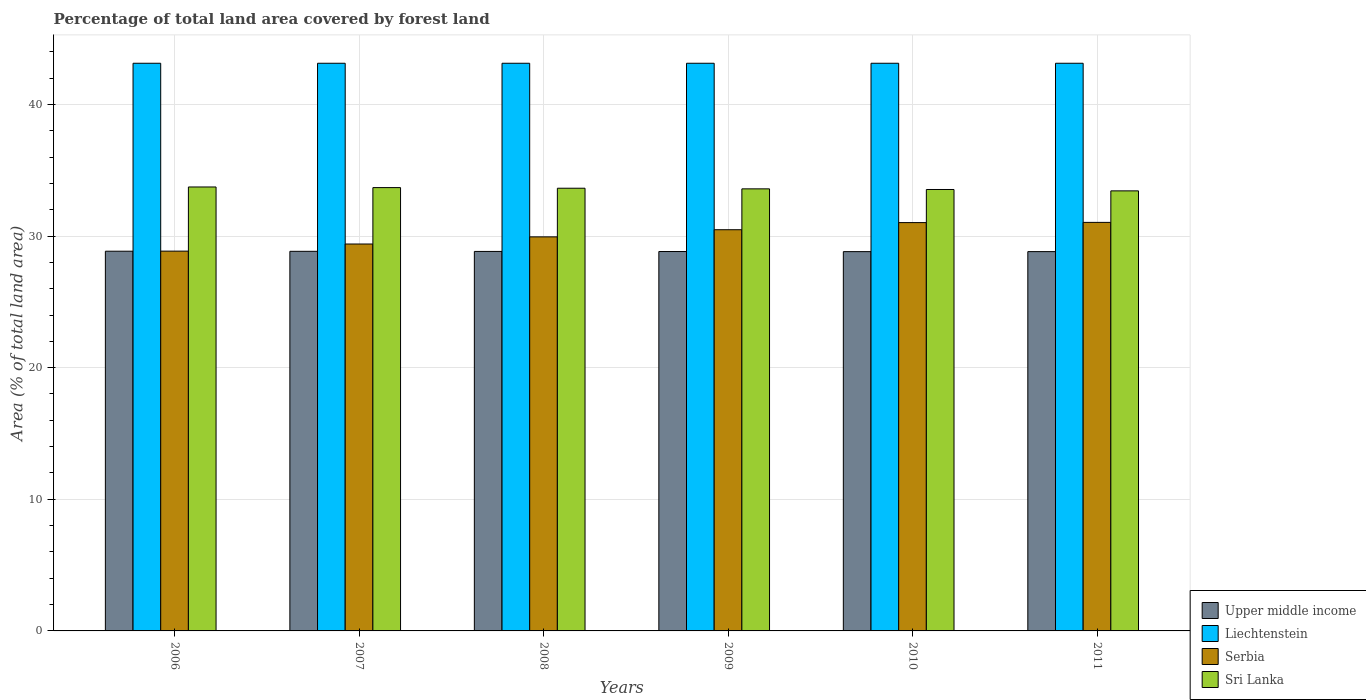How many different coloured bars are there?
Offer a very short reply. 4. Are the number of bars per tick equal to the number of legend labels?
Your answer should be compact. Yes. How many bars are there on the 5th tick from the left?
Provide a short and direct response. 4. What is the label of the 5th group of bars from the left?
Your response must be concise. 2010. What is the percentage of forest land in Sri Lanka in 2008?
Offer a terse response. 33.63. Across all years, what is the maximum percentage of forest land in Upper middle income?
Provide a short and direct response. 28.85. Across all years, what is the minimum percentage of forest land in Upper middle income?
Your answer should be very brief. 28.81. In which year was the percentage of forest land in Liechtenstein maximum?
Offer a very short reply. 2006. In which year was the percentage of forest land in Serbia minimum?
Provide a short and direct response. 2006. What is the total percentage of forest land in Sri Lanka in the graph?
Offer a terse response. 201.59. What is the difference between the percentage of forest land in Sri Lanka in 2006 and that in 2008?
Give a very brief answer. 0.1. What is the difference between the percentage of forest land in Liechtenstein in 2008 and the percentage of forest land in Sri Lanka in 2011?
Ensure brevity in your answer.  9.69. What is the average percentage of forest land in Sri Lanka per year?
Offer a terse response. 33.6. In the year 2011, what is the difference between the percentage of forest land in Liechtenstein and percentage of forest land in Serbia?
Offer a very short reply. 12.09. What is the ratio of the percentage of forest land in Sri Lanka in 2010 to that in 2011?
Keep it short and to the point. 1. Is the difference between the percentage of forest land in Liechtenstein in 2007 and 2010 greater than the difference between the percentage of forest land in Serbia in 2007 and 2010?
Keep it short and to the point. Yes. What is the difference between the highest and the second highest percentage of forest land in Serbia?
Offer a terse response. 0.02. What is the difference between the highest and the lowest percentage of forest land in Serbia?
Offer a very short reply. 2.18. In how many years, is the percentage of forest land in Upper middle income greater than the average percentage of forest land in Upper middle income taken over all years?
Your response must be concise. 3. What does the 2nd bar from the left in 2008 represents?
Offer a terse response. Liechtenstein. What does the 3rd bar from the right in 2011 represents?
Your answer should be compact. Liechtenstein. How many years are there in the graph?
Your answer should be very brief. 6. Are the values on the major ticks of Y-axis written in scientific E-notation?
Your response must be concise. No. How are the legend labels stacked?
Provide a succinct answer. Vertical. What is the title of the graph?
Keep it short and to the point. Percentage of total land area covered by forest land. Does "Somalia" appear as one of the legend labels in the graph?
Give a very brief answer. No. What is the label or title of the X-axis?
Provide a succinct answer. Years. What is the label or title of the Y-axis?
Give a very brief answer. Area (% of total land area). What is the Area (% of total land area) of Upper middle income in 2006?
Your answer should be very brief. 28.85. What is the Area (% of total land area) in Liechtenstein in 2006?
Your answer should be very brief. 43.12. What is the Area (% of total land area) in Serbia in 2006?
Provide a short and direct response. 28.85. What is the Area (% of total land area) of Sri Lanka in 2006?
Ensure brevity in your answer.  33.73. What is the Area (% of total land area) of Upper middle income in 2007?
Keep it short and to the point. 28.84. What is the Area (% of total land area) of Liechtenstein in 2007?
Offer a very short reply. 43.12. What is the Area (% of total land area) in Serbia in 2007?
Ensure brevity in your answer.  29.39. What is the Area (% of total land area) in Sri Lanka in 2007?
Give a very brief answer. 33.68. What is the Area (% of total land area) in Upper middle income in 2008?
Offer a very short reply. 28.83. What is the Area (% of total land area) of Liechtenstein in 2008?
Offer a very short reply. 43.12. What is the Area (% of total land area) of Serbia in 2008?
Keep it short and to the point. 29.94. What is the Area (% of total land area) of Sri Lanka in 2008?
Provide a succinct answer. 33.63. What is the Area (% of total land area) in Upper middle income in 2009?
Your response must be concise. 28.82. What is the Area (% of total land area) in Liechtenstein in 2009?
Your response must be concise. 43.12. What is the Area (% of total land area) of Serbia in 2009?
Provide a succinct answer. 30.48. What is the Area (% of total land area) of Sri Lanka in 2009?
Ensure brevity in your answer.  33.58. What is the Area (% of total land area) of Upper middle income in 2010?
Make the answer very short. 28.81. What is the Area (% of total land area) in Liechtenstein in 2010?
Keep it short and to the point. 43.12. What is the Area (% of total land area) in Serbia in 2010?
Offer a terse response. 31.02. What is the Area (% of total land area) of Sri Lanka in 2010?
Give a very brief answer. 33.54. What is the Area (% of total land area) of Upper middle income in 2011?
Offer a very short reply. 28.82. What is the Area (% of total land area) of Liechtenstein in 2011?
Offer a very short reply. 43.12. What is the Area (% of total land area) of Serbia in 2011?
Offer a very short reply. 31.04. What is the Area (% of total land area) in Sri Lanka in 2011?
Give a very brief answer. 33.43. Across all years, what is the maximum Area (% of total land area) of Upper middle income?
Keep it short and to the point. 28.85. Across all years, what is the maximum Area (% of total land area) in Liechtenstein?
Provide a succinct answer. 43.12. Across all years, what is the maximum Area (% of total land area) in Serbia?
Keep it short and to the point. 31.04. Across all years, what is the maximum Area (% of total land area) of Sri Lanka?
Provide a short and direct response. 33.73. Across all years, what is the minimum Area (% of total land area) in Upper middle income?
Your response must be concise. 28.81. Across all years, what is the minimum Area (% of total land area) of Liechtenstein?
Your answer should be very brief. 43.12. Across all years, what is the minimum Area (% of total land area) in Serbia?
Provide a succinct answer. 28.85. Across all years, what is the minimum Area (% of total land area) of Sri Lanka?
Keep it short and to the point. 33.43. What is the total Area (% of total land area) of Upper middle income in the graph?
Offer a very short reply. 172.97. What is the total Area (% of total land area) in Liechtenstein in the graph?
Provide a succinct answer. 258.75. What is the total Area (% of total land area) of Serbia in the graph?
Give a very brief answer. 180.72. What is the total Area (% of total land area) of Sri Lanka in the graph?
Your response must be concise. 201.59. What is the difference between the Area (% of total land area) in Upper middle income in 2006 and that in 2007?
Keep it short and to the point. 0.01. What is the difference between the Area (% of total land area) of Serbia in 2006 and that in 2007?
Your answer should be very brief. -0.54. What is the difference between the Area (% of total land area) in Sri Lanka in 2006 and that in 2007?
Your answer should be very brief. 0.05. What is the difference between the Area (% of total land area) of Upper middle income in 2006 and that in 2008?
Provide a short and direct response. 0.02. What is the difference between the Area (% of total land area) in Serbia in 2006 and that in 2008?
Your answer should be very brief. -1.08. What is the difference between the Area (% of total land area) of Sri Lanka in 2006 and that in 2008?
Keep it short and to the point. 0.1. What is the difference between the Area (% of total land area) in Upper middle income in 2006 and that in 2009?
Ensure brevity in your answer.  0.02. What is the difference between the Area (% of total land area) in Serbia in 2006 and that in 2009?
Ensure brevity in your answer.  -1.63. What is the difference between the Area (% of total land area) in Sri Lanka in 2006 and that in 2009?
Your answer should be very brief. 0.14. What is the difference between the Area (% of total land area) of Upper middle income in 2006 and that in 2010?
Ensure brevity in your answer.  0.03. What is the difference between the Area (% of total land area) in Serbia in 2006 and that in 2010?
Provide a short and direct response. -2.17. What is the difference between the Area (% of total land area) of Sri Lanka in 2006 and that in 2010?
Make the answer very short. 0.19. What is the difference between the Area (% of total land area) of Upper middle income in 2006 and that in 2011?
Offer a terse response. 0.03. What is the difference between the Area (% of total land area) of Liechtenstein in 2006 and that in 2011?
Your response must be concise. 0. What is the difference between the Area (% of total land area) in Serbia in 2006 and that in 2011?
Keep it short and to the point. -2.18. What is the difference between the Area (% of total land area) in Sri Lanka in 2006 and that in 2011?
Provide a short and direct response. 0.3. What is the difference between the Area (% of total land area) of Upper middle income in 2007 and that in 2008?
Offer a very short reply. 0.01. What is the difference between the Area (% of total land area) in Serbia in 2007 and that in 2008?
Your answer should be compact. -0.54. What is the difference between the Area (% of total land area) in Sri Lanka in 2007 and that in 2008?
Provide a succinct answer. 0.05. What is the difference between the Area (% of total land area) of Upper middle income in 2007 and that in 2009?
Ensure brevity in your answer.  0.02. What is the difference between the Area (% of total land area) in Serbia in 2007 and that in 2009?
Make the answer very short. -1.08. What is the difference between the Area (% of total land area) in Sri Lanka in 2007 and that in 2009?
Provide a short and direct response. 0.1. What is the difference between the Area (% of total land area) of Upper middle income in 2007 and that in 2010?
Your response must be concise. 0.02. What is the difference between the Area (% of total land area) of Serbia in 2007 and that in 2010?
Offer a very short reply. -1.63. What is the difference between the Area (% of total land area) of Sri Lanka in 2007 and that in 2010?
Your response must be concise. 0.14. What is the difference between the Area (% of total land area) of Upper middle income in 2007 and that in 2011?
Keep it short and to the point. 0.02. What is the difference between the Area (% of total land area) of Serbia in 2007 and that in 2011?
Your response must be concise. -1.64. What is the difference between the Area (% of total land area) of Sri Lanka in 2007 and that in 2011?
Offer a very short reply. 0.25. What is the difference between the Area (% of total land area) in Upper middle income in 2008 and that in 2009?
Offer a very short reply. 0.01. What is the difference between the Area (% of total land area) in Serbia in 2008 and that in 2009?
Your answer should be very brief. -0.54. What is the difference between the Area (% of total land area) in Sri Lanka in 2008 and that in 2009?
Provide a short and direct response. 0.05. What is the difference between the Area (% of total land area) in Upper middle income in 2008 and that in 2010?
Make the answer very short. 0.02. What is the difference between the Area (% of total land area) of Serbia in 2008 and that in 2010?
Keep it short and to the point. -1.08. What is the difference between the Area (% of total land area) of Sri Lanka in 2008 and that in 2010?
Your answer should be very brief. 0.1. What is the difference between the Area (% of total land area) in Upper middle income in 2008 and that in 2011?
Provide a succinct answer. 0.01. What is the difference between the Area (% of total land area) of Serbia in 2008 and that in 2011?
Keep it short and to the point. -1.1. What is the difference between the Area (% of total land area) of Sri Lanka in 2008 and that in 2011?
Offer a terse response. 0.2. What is the difference between the Area (% of total land area) of Upper middle income in 2009 and that in 2010?
Provide a short and direct response. 0.01. What is the difference between the Area (% of total land area) of Serbia in 2009 and that in 2010?
Provide a succinct answer. -0.54. What is the difference between the Area (% of total land area) of Sri Lanka in 2009 and that in 2010?
Offer a very short reply. 0.05. What is the difference between the Area (% of total land area) of Upper middle income in 2009 and that in 2011?
Offer a very short reply. 0.01. What is the difference between the Area (% of total land area) of Serbia in 2009 and that in 2011?
Make the answer very short. -0.56. What is the difference between the Area (% of total land area) in Sri Lanka in 2009 and that in 2011?
Make the answer very short. 0.15. What is the difference between the Area (% of total land area) of Upper middle income in 2010 and that in 2011?
Your answer should be compact. -0. What is the difference between the Area (% of total land area) in Liechtenstein in 2010 and that in 2011?
Offer a terse response. 0. What is the difference between the Area (% of total land area) in Serbia in 2010 and that in 2011?
Your answer should be very brief. -0.02. What is the difference between the Area (% of total land area) of Sri Lanka in 2010 and that in 2011?
Your response must be concise. 0.11. What is the difference between the Area (% of total land area) of Upper middle income in 2006 and the Area (% of total land area) of Liechtenstein in 2007?
Give a very brief answer. -14.28. What is the difference between the Area (% of total land area) in Upper middle income in 2006 and the Area (% of total land area) in Serbia in 2007?
Give a very brief answer. -0.55. What is the difference between the Area (% of total land area) of Upper middle income in 2006 and the Area (% of total land area) of Sri Lanka in 2007?
Your response must be concise. -4.83. What is the difference between the Area (% of total land area) in Liechtenstein in 2006 and the Area (% of total land area) in Serbia in 2007?
Provide a succinct answer. 13.73. What is the difference between the Area (% of total land area) of Liechtenstein in 2006 and the Area (% of total land area) of Sri Lanka in 2007?
Your answer should be very brief. 9.45. What is the difference between the Area (% of total land area) of Serbia in 2006 and the Area (% of total land area) of Sri Lanka in 2007?
Make the answer very short. -4.83. What is the difference between the Area (% of total land area) in Upper middle income in 2006 and the Area (% of total land area) in Liechtenstein in 2008?
Provide a succinct answer. -14.28. What is the difference between the Area (% of total land area) of Upper middle income in 2006 and the Area (% of total land area) of Serbia in 2008?
Provide a short and direct response. -1.09. What is the difference between the Area (% of total land area) of Upper middle income in 2006 and the Area (% of total land area) of Sri Lanka in 2008?
Provide a succinct answer. -4.79. What is the difference between the Area (% of total land area) of Liechtenstein in 2006 and the Area (% of total land area) of Serbia in 2008?
Give a very brief answer. 13.19. What is the difference between the Area (% of total land area) of Liechtenstein in 2006 and the Area (% of total land area) of Sri Lanka in 2008?
Keep it short and to the point. 9.49. What is the difference between the Area (% of total land area) of Serbia in 2006 and the Area (% of total land area) of Sri Lanka in 2008?
Give a very brief answer. -4.78. What is the difference between the Area (% of total land area) of Upper middle income in 2006 and the Area (% of total land area) of Liechtenstein in 2009?
Your response must be concise. -14.28. What is the difference between the Area (% of total land area) of Upper middle income in 2006 and the Area (% of total land area) of Serbia in 2009?
Keep it short and to the point. -1.63. What is the difference between the Area (% of total land area) of Upper middle income in 2006 and the Area (% of total land area) of Sri Lanka in 2009?
Your answer should be compact. -4.74. What is the difference between the Area (% of total land area) in Liechtenstein in 2006 and the Area (% of total land area) in Serbia in 2009?
Your answer should be very brief. 12.65. What is the difference between the Area (% of total land area) of Liechtenstein in 2006 and the Area (% of total land area) of Sri Lanka in 2009?
Your response must be concise. 9.54. What is the difference between the Area (% of total land area) of Serbia in 2006 and the Area (% of total land area) of Sri Lanka in 2009?
Provide a succinct answer. -4.73. What is the difference between the Area (% of total land area) of Upper middle income in 2006 and the Area (% of total land area) of Liechtenstein in 2010?
Provide a short and direct response. -14.28. What is the difference between the Area (% of total land area) of Upper middle income in 2006 and the Area (% of total land area) of Serbia in 2010?
Provide a succinct answer. -2.17. What is the difference between the Area (% of total land area) in Upper middle income in 2006 and the Area (% of total land area) in Sri Lanka in 2010?
Make the answer very short. -4.69. What is the difference between the Area (% of total land area) in Liechtenstein in 2006 and the Area (% of total land area) in Serbia in 2010?
Give a very brief answer. 12.11. What is the difference between the Area (% of total land area) in Liechtenstein in 2006 and the Area (% of total land area) in Sri Lanka in 2010?
Make the answer very short. 9.59. What is the difference between the Area (% of total land area) of Serbia in 2006 and the Area (% of total land area) of Sri Lanka in 2010?
Your response must be concise. -4.68. What is the difference between the Area (% of total land area) in Upper middle income in 2006 and the Area (% of total land area) in Liechtenstein in 2011?
Ensure brevity in your answer.  -14.28. What is the difference between the Area (% of total land area) in Upper middle income in 2006 and the Area (% of total land area) in Serbia in 2011?
Ensure brevity in your answer.  -2.19. What is the difference between the Area (% of total land area) in Upper middle income in 2006 and the Area (% of total land area) in Sri Lanka in 2011?
Offer a terse response. -4.58. What is the difference between the Area (% of total land area) of Liechtenstein in 2006 and the Area (% of total land area) of Serbia in 2011?
Keep it short and to the point. 12.09. What is the difference between the Area (% of total land area) of Liechtenstein in 2006 and the Area (% of total land area) of Sri Lanka in 2011?
Offer a terse response. 9.69. What is the difference between the Area (% of total land area) in Serbia in 2006 and the Area (% of total land area) in Sri Lanka in 2011?
Keep it short and to the point. -4.58. What is the difference between the Area (% of total land area) of Upper middle income in 2007 and the Area (% of total land area) of Liechtenstein in 2008?
Offer a terse response. -14.29. What is the difference between the Area (% of total land area) in Upper middle income in 2007 and the Area (% of total land area) in Serbia in 2008?
Your answer should be compact. -1.1. What is the difference between the Area (% of total land area) of Upper middle income in 2007 and the Area (% of total land area) of Sri Lanka in 2008?
Offer a terse response. -4.79. What is the difference between the Area (% of total land area) in Liechtenstein in 2007 and the Area (% of total land area) in Serbia in 2008?
Your answer should be very brief. 13.19. What is the difference between the Area (% of total land area) in Liechtenstein in 2007 and the Area (% of total land area) in Sri Lanka in 2008?
Offer a terse response. 9.49. What is the difference between the Area (% of total land area) in Serbia in 2007 and the Area (% of total land area) in Sri Lanka in 2008?
Provide a succinct answer. -4.24. What is the difference between the Area (% of total land area) in Upper middle income in 2007 and the Area (% of total land area) in Liechtenstein in 2009?
Your answer should be very brief. -14.29. What is the difference between the Area (% of total land area) in Upper middle income in 2007 and the Area (% of total land area) in Serbia in 2009?
Give a very brief answer. -1.64. What is the difference between the Area (% of total land area) of Upper middle income in 2007 and the Area (% of total land area) of Sri Lanka in 2009?
Provide a short and direct response. -4.75. What is the difference between the Area (% of total land area) of Liechtenstein in 2007 and the Area (% of total land area) of Serbia in 2009?
Offer a very short reply. 12.65. What is the difference between the Area (% of total land area) in Liechtenstein in 2007 and the Area (% of total land area) in Sri Lanka in 2009?
Provide a short and direct response. 9.54. What is the difference between the Area (% of total land area) of Serbia in 2007 and the Area (% of total land area) of Sri Lanka in 2009?
Make the answer very short. -4.19. What is the difference between the Area (% of total land area) of Upper middle income in 2007 and the Area (% of total land area) of Liechtenstein in 2010?
Offer a very short reply. -14.29. What is the difference between the Area (% of total land area) of Upper middle income in 2007 and the Area (% of total land area) of Serbia in 2010?
Your response must be concise. -2.18. What is the difference between the Area (% of total land area) of Upper middle income in 2007 and the Area (% of total land area) of Sri Lanka in 2010?
Your answer should be compact. -4.7. What is the difference between the Area (% of total land area) in Liechtenstein in 2007 and the Area (% of total land area) in Serbia in 2010?
Give a very brief answer. 12.11. What is the difference between the Area (% of total land area) of Liechtenstein in 2007 and the Area (% of total land area) of Sri Lanka in 2010?
Your answer should be very brief. 9.59. What is the difference between the Area (% of total land area) in Serbia in 2007 and the Area (% of total land area) in Sri Lanka in 2010?
Your answer should be very brief. -4.14. What is the difference between the Area (% of total land area) in Upper middle income in 2007 and the Area (% of total land area) in Liechtenstein in 2011?
Offer a very short reply. -14.29. What is the difference between the Area (% of total land area) in Upper middle income in 2007 and the Area (% of total land area) in Serbia in 2011?
Provide a short and direct response. -2.2. What is the difference between the Area (% of total land area) in Upper middle income in 2007 and the Area (% of total land area) in Sri Lanka in 2011?
Make the answer very short. -4.59. What is the difference between the Area (% of total land area) of Liechtenstein in 2007 and the Area (% of total land area) of Serbia in 2011?
Provide a short and direct response. 12.09. What is the difference between the Area (% of total land area) in Liechtenstein in 2007 and the Area (% of total land area) in Sri Lanka in 2011?
Make the answer very short. 9.69. What is the difference between the Area (% of total land area) in Serbia in 2007 and the Area (% of total land area) in Sri Lanka in 2011?
Offer a terse response. -4.04. What is the difference between the Area (% of total land area) in Upper middle income in 2008 and the Area (% of total land area) in Liechtenstein in 2009?
Give a very brief answer. -14.3. What is the difference between the Area (% of total land area) in Upper middle income in 2008 and the Area (% of total land area) in Serbia in 2009?
Your response must be concise. -1.65. What is the difference between the Area (% of total land area) in Upper middle income in 2008 and the Area (% of total land area) in Sri Lanka in 2009?
Provide a succinct answer. -4.75. What is the difference between the Area (% of total land area) in Liechtenstein in 2008 and the Area (% of total land area) in Serbia in 2009?
Give a very brief answer. 12.65. What is the difference between the Area (% of total land area) in Liechtenstein in 2008 and the Area (% of total land area) in Sri Lanka in 2009?
Your answer should be very brief. 9.54. What is the difference between the Area (% of total land area) in Serbia in 2008 and the Area (% of total land area) in Sri Lanka in 2009?
Your response must be concise. -3.65. What is the difference between the Area (% of total land area) of Upper middle income in 2008 and the Area (% of total land area) of Liechtenstein in 2010?
Provide a succinct answer. -14.3. What is the difference between the Area (% of total land area) of Upper middle income in 2008 and the Area (% of total land area) of Serbia in 2010?
Give a very brief answer. -2.19. What is the difference between the Area (% of total land area) in Upper middle income in 2008 and the Area (% of total land area) in Sri Lanka in 2010?
Provide a succinct answer. -4.71. What is the difference between the Area (% of total land area) of Liechtenstein in 2008 and the Area (% of total land area) of Serbia in 2010?
Keep it short and to the point. 12.11. What is the difference between the Area (% of total land area) of Liechtenstein in 2008 and the Area (% of total land area) of Sri Lanka in 2010?
Your answer should be very brief. 9.59. What is the difference between the Area (% of total land area) in Serbia in 2008 and the Area (% of total land area) in Sri Lanka in 2010?
Offer a terse response. -3.6. What is the difference between the Area (% of total land area) in Upper middle income in 2008 and the Area (% of total land area) in Liechtenstein in 2011?
Your response must be concise. -14.3. What is the difference between the Area (% of total land area) of Upper middle income in 2008 and the Area (% of total land area) of Serbia in 2011?
Your answer should be very brief. -2.21. What is the difference between the Area (% of total land area) of Upper middle income in 2008 and the Area (% of total land area) of Sri Lanka in 2011?
Ensure brevity in your answer.  -4.6. What is the difference between the Area (% of total land area) of Liechtenstein in 2008 and the Area (% of total land area) of Serbia in 2011?
Ensure brevity in your answer.  12.09. What is the difference between the Area (% of total land area) of Liechtenstein in 2008 and the Area (% of total land area) of Sri Lanka in 2011?
Make the answer very short. 9.69. What is the difference between the Area (% of total land area) of Serbia in 2008 and the Area (% of total land area) of Sri Lanka in 2011?
Your answer should be very brief. -3.49. What is the difference between the Area (% of total land area) of Upper middle income in 2009 and the Area (% of total land area) of Liechtenstein in 2010?
Your answer should be very brief. -14.3. What is the difference between the Area (% of total land area) of Upper middle income in 2009 and the Area (% of total land area) of Serbia in 2010?
Provide a short and direct response. -2.2. What is the difference between the Area (% of total land area) in Upper middle income in 2009 and the Area (% of total land area) in Sri Lanka in 2010?
Keep it short and to the point. -4.71. What is the difference between the Area (% of total land area) of Liechtenstein in 2009 and the Area (% of total land area) of Serbia in 2010?
Provide a short and direct response. 12.11. What is the difference between the Area (% of total land area) of Liechtenstein in 2009 and the Area (% of total land area) of Sri Lanka in 2010?
Offer a very short reply. 9.59. What is the difference between the Area (% of total land area) in Serbia in 2009 and the Area (% of total land area) in Sri Lanka in 2010?
Provide a short and direct response. -3.06. What is the difference between the Area (% of total land area) of Upper middle income in 2009 and the Area (% of total land area) of Liechtenstein in 2011?
Your answer should be very brief. -14.3. What is the difference between the Area (% of total land area) in Upper middle income in 2009 and the Area (% of total land area) in Serbia in 2011?
Make the answer very short. -2.21. What is the difference between the Area (% of total land area) in Upper middle income in 2009 and the Area (% of total land area) in Sri Lanka in 2011?
Ensure brevity in your answer.  -4.61. What is the difference between the Area (% of total land area) of Liechtenstein in 2009 and the Area (% of total land area) of Serbia in 2011?
Ensure brevity in your answer.  12.09. What is the difference between the Area (% of total land area) of Liechtenstein in 2009 and the Area (% of total land area) of Sri Lanka in 2011?
Make the answer very short. 9.69. What is the difference between the Area (% of total land area) of Serbia in 2009 and the Area (% of total land area) of Sri Lanka in 2011?
Your answer should be compact. -2.95. What is the difference between the Area (% of total land area) of Upper middle income in 2010 and the Area (% of total land area) of Liechtenstein in 2011?
Offer a terse response. -14.31. What is the difference between the Area (% of total land area) in Upper middle income in 2010 and the Area (% of total land area) in Serbia in 2011?
Your answer should be compact. -2.22. What is the difference between the Area (% of total land area) of Upper middle income in 2010 and the Area (% of total land area) of Sri Lanka in 2011?
Keep it short and to the point. -4.62. What is the difference between the Area (% of total land area) of Liechtenstein in 2010 and the Area (% of total land area) of Serbia in 2011?
Provide a succinct answer. 12.09. What is the difference between the Area (% of total land area) in Liechtenstein in 2010 and the Area (% of total land area) in Sri Lanka in 2011?
Offer a very short reply. 9.69. What is the difference between the Area (% of total land area) of Serbia in 2010 and the Area (% of total land area) of Sri Lanka in 2011?
Provide a short and direct response. -2.41. What is the average Area (% of total land area) in Upper middle income per year?
Provide a short and direct response. 28.83. What is the average Area (% of total land area) of Liechtenstein per year?
Ensure brevity in your answer.  43.12. What is the average Area (% of total land area) in Serbia per year?
Make the answer very short. 30.12. What is the average Area (% of total land area) in Sri Lanka per year?
Provide a succinct answer. 33.6. In the year 2006, what is the difference between the Area (% of total land area) of Upper middle income and Area (% of total land area) of Liechtenstein?
Keep it short and to the point. -14.28. In the year 2006, what is the difference between the Area (% of total land area) in Upper middle income and Area (% of total land area) in Serbia?
Offer a terse response. -0.01. In the year 2006, what is the difference between the Area (% of total land area) in Upper middle income and Area (% of total land area) in Sri Lanka?
Keep it short and to the point. -4.88. In the year 2006, what is the difference between the Area (% of total land area) in Liechtenstein and Area (% of total land area) in Serbia?
Make the answer very short. 14.27. In the year 2006, what is the difference between the Area (% of total land area) in Liechtenstein and Area (% of total land area) in Sri Lanka?
Keep it short and to the point. 9.4. In the year 2006, what is the difference between the Area (% of total land area) in Serbia and Area (% of total land area) in Sri Lanka?
Make the answer very short. -4.87. In the year 2007, what is the difference between the Area (% of total land area) in Upper middle income and Area (% of total land area) in Liechtenstein?
Provide a short and direct response. -14.29. In the year 2007, what is the difference between the Area (% of total land area) in Upper middle income and Area (% of total land area) in Serbia?
Your answer should be compact. -0.56. In the year 2007, what is the difference between the Area (% of total land area) in Upper middle income and Area (% of total land area) in Sri Lanka?
Your answer should be compact. -4.84. In the year 2007, what is the difference between the Area (% of total land area) of Liechtenstein and Area (% of total land area) of Serbia?
Make the answer very short. 13.73. In the year 2007, what is the difference between the Area (% of total land area) of Liechtenstein and Area (% of total land area) of Sri Lanka?
Your response must be concise. 9.45. In the year 2007, what is the difference between the Area (% of total land area) in Serbia and Area (% of total land area) in Sri Lanka?
Ensure brevity in your answer.  -4.28. In the year 2008, what is the difference between the Area (% of total land area) in Upper middle income and Area (% of total land area) in Liechtenstein?
Keep it short and to the point. -14.3. In the year 2008, what is the difference between the Area (% of total land area) in Upper middle income and Area (% of total land area) in Serbia?
Give a very brief answer. -1.11. In the year 2008, what is the difference between the Area (% of total land area) in Upper middle income and Area (% of total land area) in Sri Lanka?
Make the answer very short. -4.8. In the year 2008, what is the difference between the Area (% of total land area) of Liechtenstein and Area (% of total land area) of Serbia?
Provide a short and direct response. 13.19. In the year 2008, what is the difference between the Area (% of total land area) of Liechtenstein and Area (% of total land area) of Sri Lanka?
Keep it short and to the point. 9.49. In the year 2008, what is the difference between the Area (% of total land area) of Serbia and Area (% of total land area) of Sri Lanka?
Your response must be concise. -3.69. In the year 2009, what is the difference between the Area (% of total land area) of Upper middle income and Area (% of total land area) of Liechtenstein?
Your response must be concise. -14.3. In the year 2009, what is the difference between the Area (% of total land area) of Upper middle income and Area (% of total land area) of Serbia?
Your response must be concise. -1.66. In the year 2009, what is the difference between the Area (% of total land area) in Upper middle income and Area (% of total land area) in Sri Lanka?
Your response must be concise. -4.76. In the year 2009, what is the difference between the Area (% of total land area) in Liechtenstein and Area (% of total land area) in Serbia?
Make the answer very short. 12.65. In the year 2009, what is the difference between the Area (% of total land area) in Liechtenstein and Area (% of total land area) in Sri Lanka?
Give a very brief answer. 9.54. In the year 2009, what is the difference between the Area (% of total land area) of Serbia and Area (% of total land area) of Sri Lanka?
Give a very brief answer. -3.11. In the year 2010, what is the difference between the Area (% of total land area) in Upper middle income and Area (% of total land area) in Liechtenstein?
Provide a short and direct response. -14.31. In the year 2010, what is the difference between the Area (% of total land area) in Upper middle income and Area (% of total land area) in Serbia?
Your answer should be compact. -2.21. In the year 2010, what is the difference between the Area (% of total land area) of Upper middle income and Area (% of total land area) of Sri Lanka?
Ensure brevity in your answer.  -4.72. In the year 2010, what is the difference between the Area (% of total land area) in Liechtenstein and Area (% of total land area) in Serbia?
Give a very brief answer. 12.11. In the year 2010, what is the difference between the Area (% of total land area) in Liechtenstein and Area (% of total land area) in Sri Lanka?
Your answer should be very brief. 9.59. In the year 2010, what is the difference between the Area (% of total land area) of Serbia and Area (% of total land area) of Sri Lanka?
Give a very brief answer. -2.52. In the year 2011, what is the difference between the Area (% of total land area) of Upper middle income and Area (% of total land area) of Liechtenstein?
Your answer should be compact. -14.31. In the year 2011, what is the difference between the Area (% of total land area) in Upper middle income and Area (% of total land area) in Serbia?
Your response must be concise. -2.22. In the year 2011, what is the difference between the Area (% of total land area) of Upper middle income and Area (% of total land area) of Sri Lanka?
Offer a very short reply. -4.61. In the year 2011, what is the difference between the Area (% of total land area) in Liechtenstein and Area (% of total land area) in Serbia?
Make the answer very short. 12.09. In the year 2011, what is the difference between the Area (% of total land area) in Liechtenstein and Area (% of total land area) in Sri Lanka?
Provide a short and direct response. 9.69. In the year 2011, what is the difference between the Area (% of total land area) in Serbia and Area (% of total land area) in Sri Lanka?
Your answer should be compact. -2.39. What is the ratio of the Area (% of total land area) in Upper middle income in 2006 to that in 2007?
Provide a short and direct response. 1. What is the ratio of the Area (% of total land area) in Liechtenstein in 2006 to that in 2007?
Ensure brevity in your answer.  1. What is the ratio of the Area (% of total land area) in Serbia in 2006 to that in 2007?
Provide a short and direct response. 0.98. What is the ratio of the Area (% of total land area) of Sri Lanka in 2006 to that in 2007?
Your response must be concise. 1. What is the ratio of the Area (% of total land area) of Serbia in 2006 to that in 2008?
Give a very brief answer. 0.96. What is the ratio of the Area (% of total land area) in Sri Lanka in 2006 to that in 2008?
Your answer should be very brief. 1. What is the ratio of the Area (% of total land area) in Upper middle income in 2006 to that in 2009?
Your answer should be very brief. 1. What is the ratio of the Area (% of total land area) of Liechtenstein in 2006 to that in 2009?
Your answer should be compact. 1. What is the ratio of the Area (% of total land area) of Serbia in 2006 to that in 2009?
Offer a very short reply. 0.95. What is the ratio of the Area (% of total land area) in Serbia in 2006 to that in 2010?
Provide a short and direct response. 0.93. What is the ratio of the Area (% of total land area) in Upper middle income in 2006 to that in 2011?
Provide a short and direct response. 1. What is the ratio of the Area (% of total land area) of Liechtenstein in 2006 to that in 2011?
Your answer should be very brief. 1. What is the ratio of the Area (% of total land area) in Serbia in 2006 to that in 2011?
Offer a terse response. 0.93. What is the ratio of the Area (% of total land area) in Sri Lanka in 2006 to that in 2011?
Keep it short and to the point. 1.01. What is the ratio of the Area (% of total land area) in Serbia in 2007 to that in 2008?
Make the answer very short. 0.98. What is the ratio of the Area (% of total land area) of Upper middle income in 2007 to that in 2009?
Make the answer very short. 1. What is the ratio of the Area (% of total land area) of Liechtenstein in 2007 to that in 2009?
Offer a very short reply. 1. What is the ratio of the Area (% of total land area) of Serbia in 2007 to that in 2009?
Give a very brief answer. 0.96. What is the ratio of the Area (% of total land area) of Upper middle income in 2007 to that in 2010?
Your answer should be very brief. 1. What is the ratio of the Area (% of total land area) in Liechtenstein in 2007 to that in 2010?
Ensure brevity in your answer.  1. What is the ratio of the Area (% of total land area) of Serbia in 2007 to that in 2010?
Provide a short and direct response. 0.95. What is the ratio of the Area (% of total land area) of Upper middle income in 2007 to that in 2011?
Provide a succinct answer. 1. What is the ratio of the Area (% of total land area) of Serbia in 2007 to that in 2011?
Provide a succinct answer. 0.95. What is the ratio of the Area (% of total land area) in Sri Lanka in 2007 to that in 2011?
Ensure brevity in your answer.  1.01. What is the ratio of the Area (% of total land area) of Upper middle income in 2008 to that in 2009?
Make the answer very short. 1. What is the ratio of the Area (% of total land area) of Serbia in 2008 to that in 2009?
Make the answer very short. 0.98. What is the ratio of the Area (% of total land area) of Sri Lanka in 2008 to that in 2009?
Your answer should be compact. 1. What is the ratio of the Area (% of total land area) in Liechtenstein in 2008 to that in 2010?
Give a very brief answer. 1. What is the ratio of the Area (% of total land area) in Serbia in 2008 to that in 2010?
Offer a terse response. 0.97. What is the ratio of the Area (% of total land area) of Liechtenstein in 2008 to that in 2011?
Ensure brevity in your answer.  1. What is the ratio of the Area (% of total land area) in Serbia in 2008 to that in 2011?
Provide a short and direct response. 0.96. What is the ratio of the Area (% of total land area) of Liechtenstein in 2009 to that in 2010?
Keep it short and to the point. 1. What is the ratio of the Area (% of total land area) in Serbia in 2009 to that in 2010?
Your answer should be very brief. 0.98. What is the ratio of the Area (% of total land area) in Upper middle income in 2009 to that in 2011?
Offer a terse response. 1. What is the ratio of the Area (% of total land area) of Serbia in 2009 to that in 2011?
Your answer should be very brief. 0.98. What is the ratio of the Area (% of total land area) in Liechtenstein in 2010 to that in 2011?
Make the answer very short. 1. What is the difference between the highest and the second highest Area (% of total land area) of Upper middle income?
Offer a very short reply. 0.01. What is the difference between the highest and the second highest Area (% of total land area) in Liechtenstein?
Offer a terse response. 0. What is the difference between the highest and the second highest Area (% of total land area) of Serbia?
Provide a short and direct response. 0.02. What is the difference between the highest and the second highest Area (% of total land area) of Sri Lanka?
Offer a terse response. 0.05. What is the difference between the highest and the lowest Area (% of total land area) in Upper middle income?
Your response must be concise. 0.03. What is the difference between the highest and the lowest Area (% of total land area) of Liechtenstein?
Offer a very short reply. 0. What is the difference between the highest and the lowest Area (% of total land area) of Serbia?
Offer a terse response. 2.18. What is the difference between the highest and the lowest Area (% of total land area) in Sri Lanka?
Offer a very short reply. 0.3. 